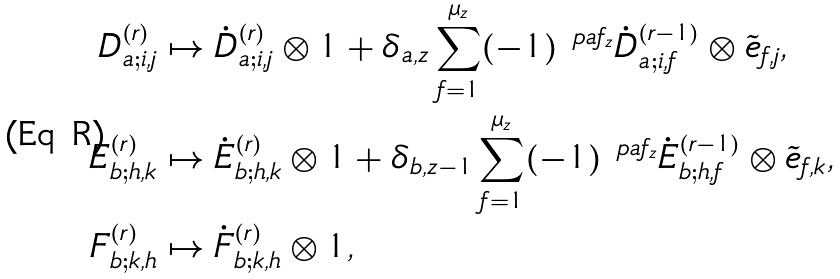Convert formula to latex. <formula><loc_0><loc_0><loc_500><loc_500>D _ { a ; i , j } ^ { ( r ) } & \mapsto \dot { D } _ { a ; i , j } ^ { ( r ) } \otimes 1 + \delta _ { a , z } \sum _ { f = 1 } ^ { \mu _ { z } } ( - 1 ) ^ { \ p a { f } _ { z } } \dot { D } _ { a ; i , f } ^ { ( r - 1 ) } \otimes \tilde { e } _ { f , j } , \\ E _ { b ; h , k } ^ { ( r ) } & \mapsto \dot { E } _ { b ; h , k } ^ { ( r ) } \otimes 1 + \delta _ { b , z - 1 } \sum _ { f = 1 } ^ { \mu _ { z } } ( - 1 ) ^ { \ p a { f } _ { z } } \dot { E } _ { b ; h , f } ^ { ( r - 1 ) } \otimes \tilde { e } _ { f , k } , \\ F _ { b ; k , h } ^ { ( r ) } & \mapsto \dot { F } _ { b ; k , h } ^ { ( r ) } \otimes 1 ,</formula> 